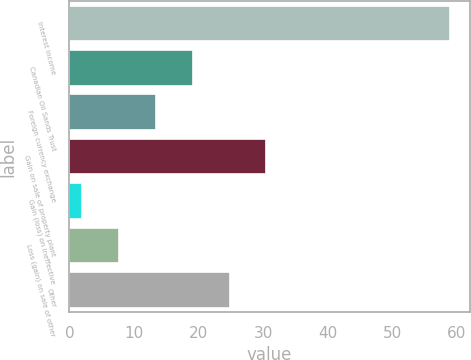Convert chart. <chart><loc_0><loc_0><loc_500><loc_500><bar_chart><fcel>Interest income<fcel>Canadian Oil Sands Trust<fcel>Foreign currency exchange<fcel>Gain on sale of property plant<fcel>Gain (loss) on ineffective<fcel>Loss (gain) on sale of other<fcel>Other<nl><fcel>59<fcel>19.1<fcel>13.4<fcel>30.5<fcel>2<fcel>7.7<fcel>24.8<nl></chart> 